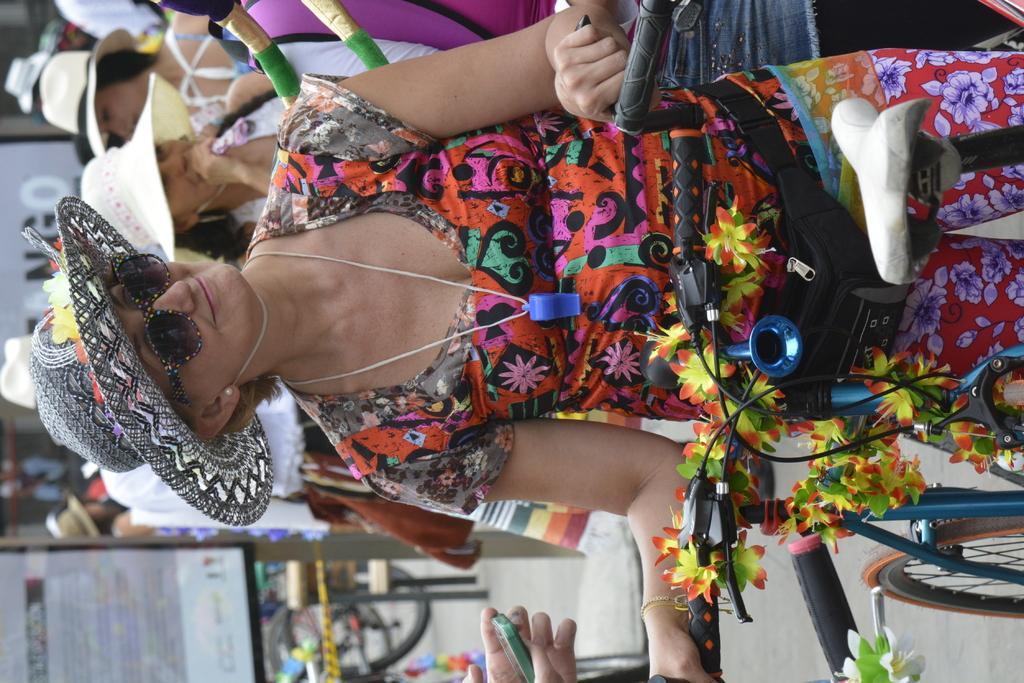How would you summarize this image in a sentence or two? In this image there is a woman standing. She is holding the handle of a cycle. She is wearing a hat and sunglasses. Behind her there are many people standing. In the bottom left there is a board on the road. 